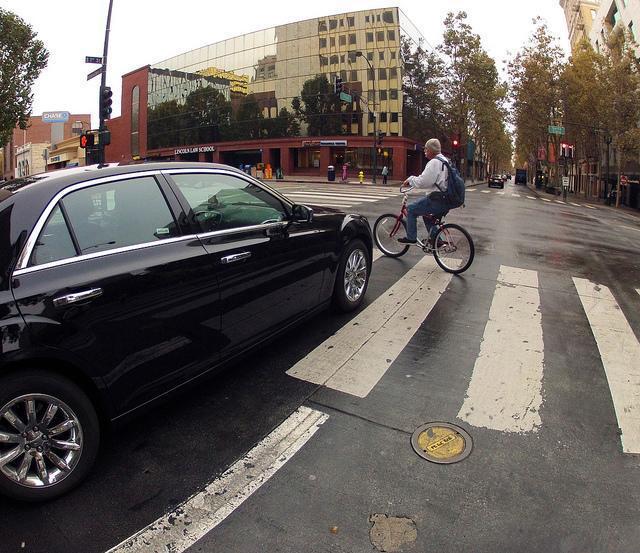How many cups are near the fridge?
Give a very brief answer. 0. 